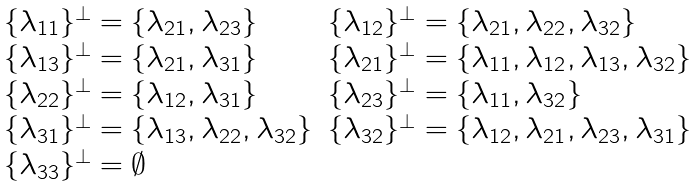<formula> <loc_0><loc_0><loc_500><loc_500>\begin{array} { l l } \{ \lambda _ { 1 1 } \} ^ { \perp } = \{ \lambda _ { 2 1 } , \lambda _ { 2 3 } \} & \{ \lambda _ { 1 2 } \} ^ { \perp } = \{ \lambda _ { 2 1 } , \lambda _ { 2 2 } , \lambda _ { 3 2 } \} \\ \{ \lambda _ { 1 3 } \} ^ { \perp } = \{ \lambda _ { 2 1 } , \lambda _ { 3 1 } \} & \{ \lambda _ { 2 1 } \} ^ { \perp } = \{ \lambda _ { 1 1 } , \lambda _ { 1 2 } , \lambda _ { 1 3 } , \lambda _ { 3 2 } \} \\ \{ \lambda _ { 2 2 } \} ^ { \perp } = \{ \lambda _ { 1 2 } , \lambda _ { 3 1 } \} & \{ \lambda _ { 2 3 } \} ^ { \perp } = \{ \lambda _ { 1 1 } , \lambda _ { 3 2 } \} \\ \{ \lambda _ { 3 1 } \} ^ { \perp } = \{ \lambda _ { 1 3 } , \lambda _ { 2 2 } , \lambda _ { 3 2 } \} & \{ \lambda _ { 3 2 } \} ^ { \perp } = \{ \lambda _ { 1 2 } , \lambda _ { 2 1 } , \lambda _ { 2 3 } , \lambda _ { 3 1 } \} \\ \{ \lambda _ { 3 3 } \} ^ { \perp } = \emptyset & \end{array}</formula> 